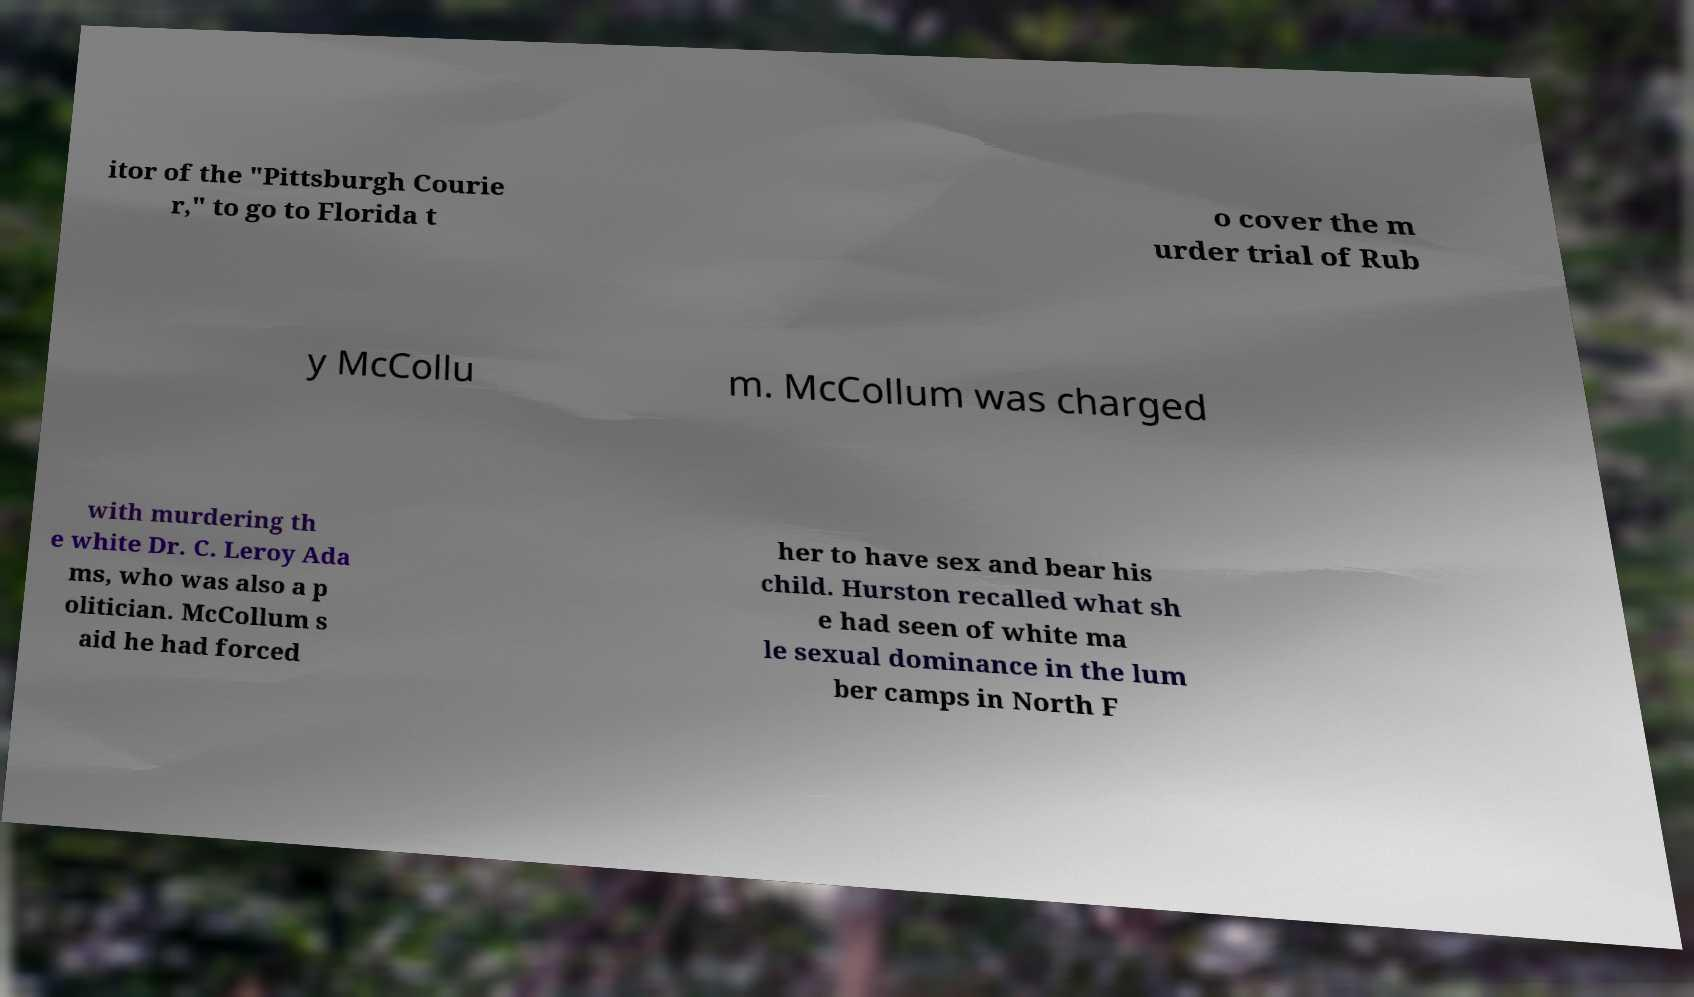For documentation purposes, I need the text within this image transcribed. Could you provide that? itor of the "Pittsburgh Courie r," to go to Florida t o cover the m urder trial of Rub y McCollu m. McCollum was charged with murdering th e white Dr. C. Leroy Ada ms, who was also a p olitician. McCollum s aid he had forced her to have sex and bear his child. Hurston recalled what sh e had seen of white ma le sexual dominance in the lum ber camps in North F 